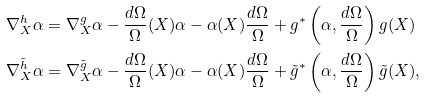Convert formula to latex. <formula><loc_0><loc_0><loc_500><loc_500>\nabla ^ { h } _ { X } \alpha & = \nabla ^ { g } _ { X } \alpha - \frac { d \Omega } { \Omega } ( X ) \alpha - \alpha ( X ) \frac { d \Omega } { \Omega } + g ^ { * } \left ( \alpha , \frac { d \Omega } { \Omega } \right ) g ( X ) \\ \nabla ^ { \tilde { h } } _ { X } \alpha & = \nabla ^ { \tilde { g } } _ { X } \alpha - \frac { d \Omega } { \Omega } ( X ) \alpha - \alpha ( X ) \frac { d \Omega } { \Omega } + \tilde { g } ^ { * } \left ( \alpha , \frac { d \Omega } { \Omega } \right ) \tilde { g } ( X ) ,</formula> 